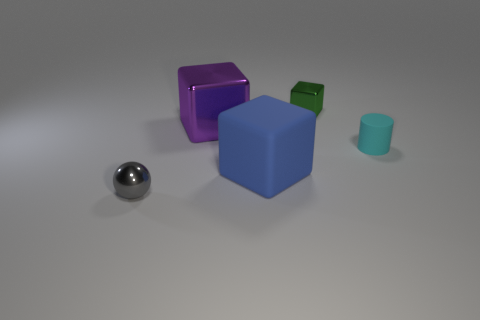Is the rubber block the same size as the cyan rubber object?
Provide a short and direct response. No. How many other objects are the same shape as the big blue matte thing?
Give a very brief answer. 2. There is a small metallic thing on the right side of the tiny gray metal object; what is its shape?
Your answer should be compact. Cube. There is a tiny shiny thing that is in front of the small cyan cylinder; does it have the same shape as the matte object on the right side of the blue rubber block?
Give a very brief answer. No. Is the number of tiny green things that are in front of the tiny cylinder the same as the number of purple metallic objects?
Give a very brief answer. No. Are there any other things that have the same size as the cyan matte cylinder?
Offer a very short reply. Yes. There is another big blue object that is the same shape as the large metallic thing; what material is it?
Your answer should be very brief. Rubber. The thing to the right of the small metal object behind the tiny gray object is what shape?
Provide a short and direct response. Cylinder. Do the tiny object that is left of the green cube and the small green block have the same material?
Make the answer very short. Yes. Are there the same number of small green objects left of the green shiny object and cyan objects that are to the left of the blue cube?
Offer a terse response. Yes. 